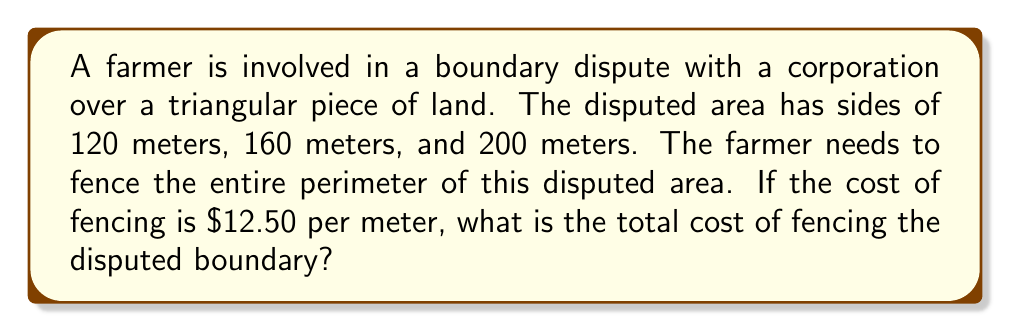Provide a solution to this math problem. To solve this problem, we'll follow these steps:

1. Calculate the perimeter of the triangular disputed area:
   $$P = a + b + c$$
   where $P$ is the perimeter, and $a$, $b$, and $c$ are the side lengths.
   
   $$P = 120 \text{ m} + 160 \text{ m} + 200 \text{ m} = 480 \text{ m}$$

2. Calculate the cost of fencing per meter:
   The cost is given as $12.50 per meter.

3. Calculate the total cost of fencing:
   $$\text{Total Cost} = \text{Perimeter} \times \text{Cost per meter}$$
   $$\text{Total Cost} = 480 \text{ m} \times \$12.50/\text{m} = \$6,000$$

Therefore, the total cost of fencing the disputed boundary is $6,000.
Answer: $6,000 